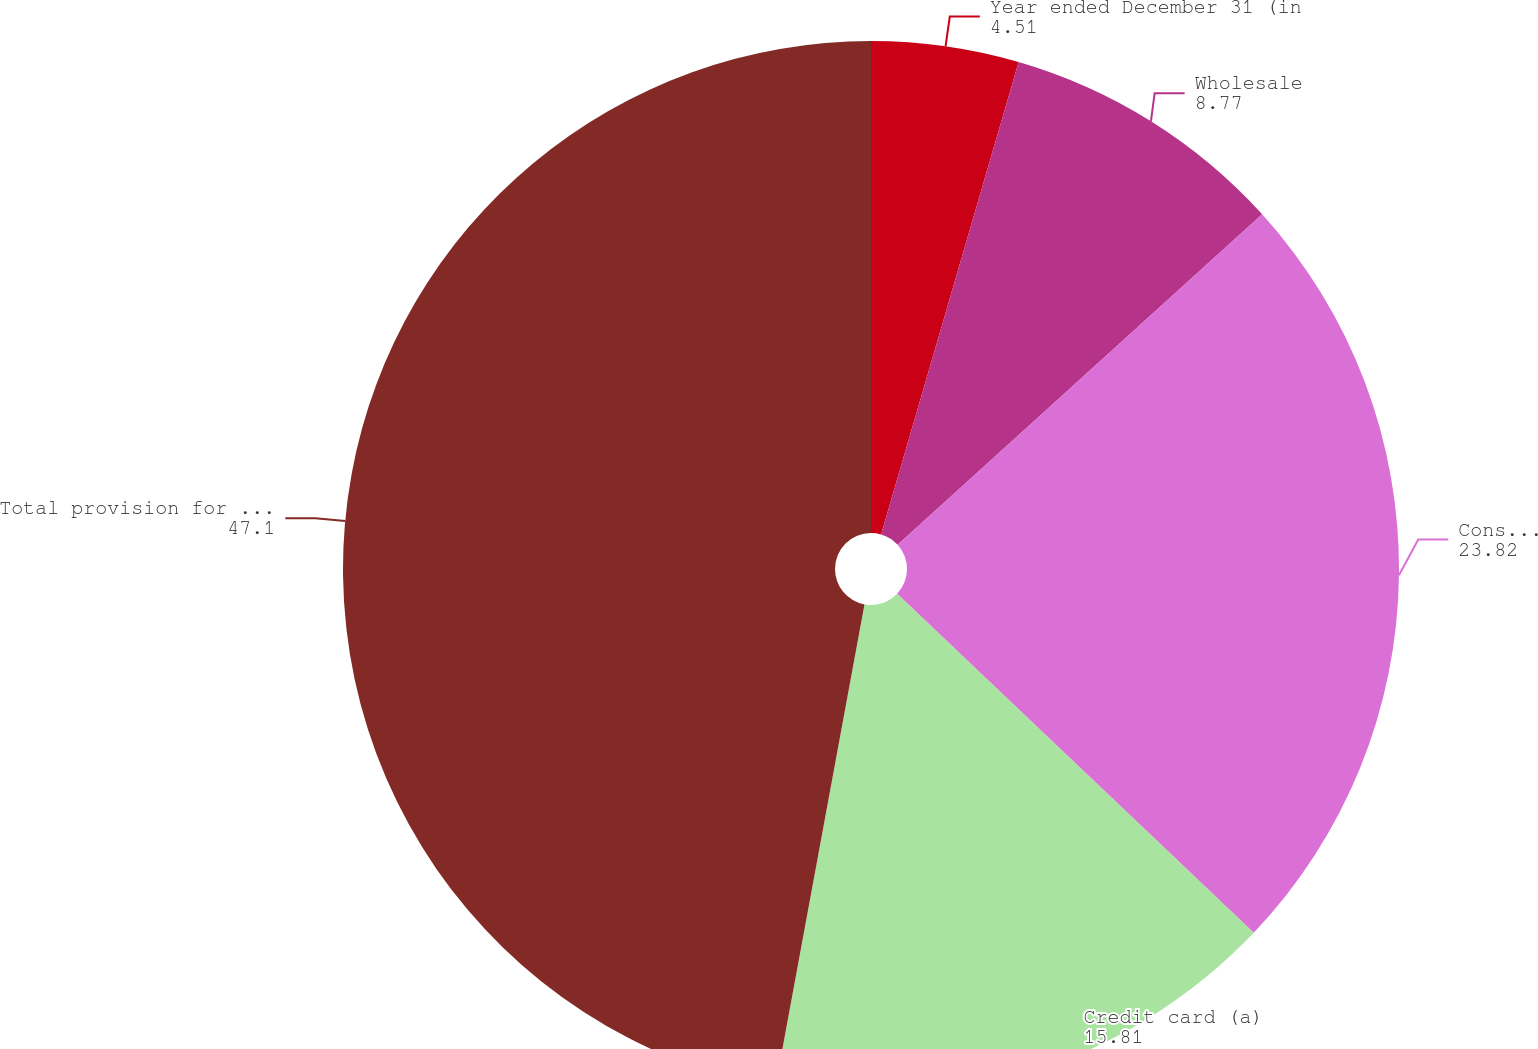Convert chart to OTSL. <chart><loc_0><loc_0><loc_500><loc_500><pie_chart><fcel>Year ended December 31 (in<fcel>Wholesale<fcel>Consumer excluding credit card<fcel>Credit card (a)<fcel>Total provision for credit<nl><fcel>4.51%<fcel>8.77%<fcel>23.82%<fcel>15.81%<fcel>47.1%<nl></chart> 